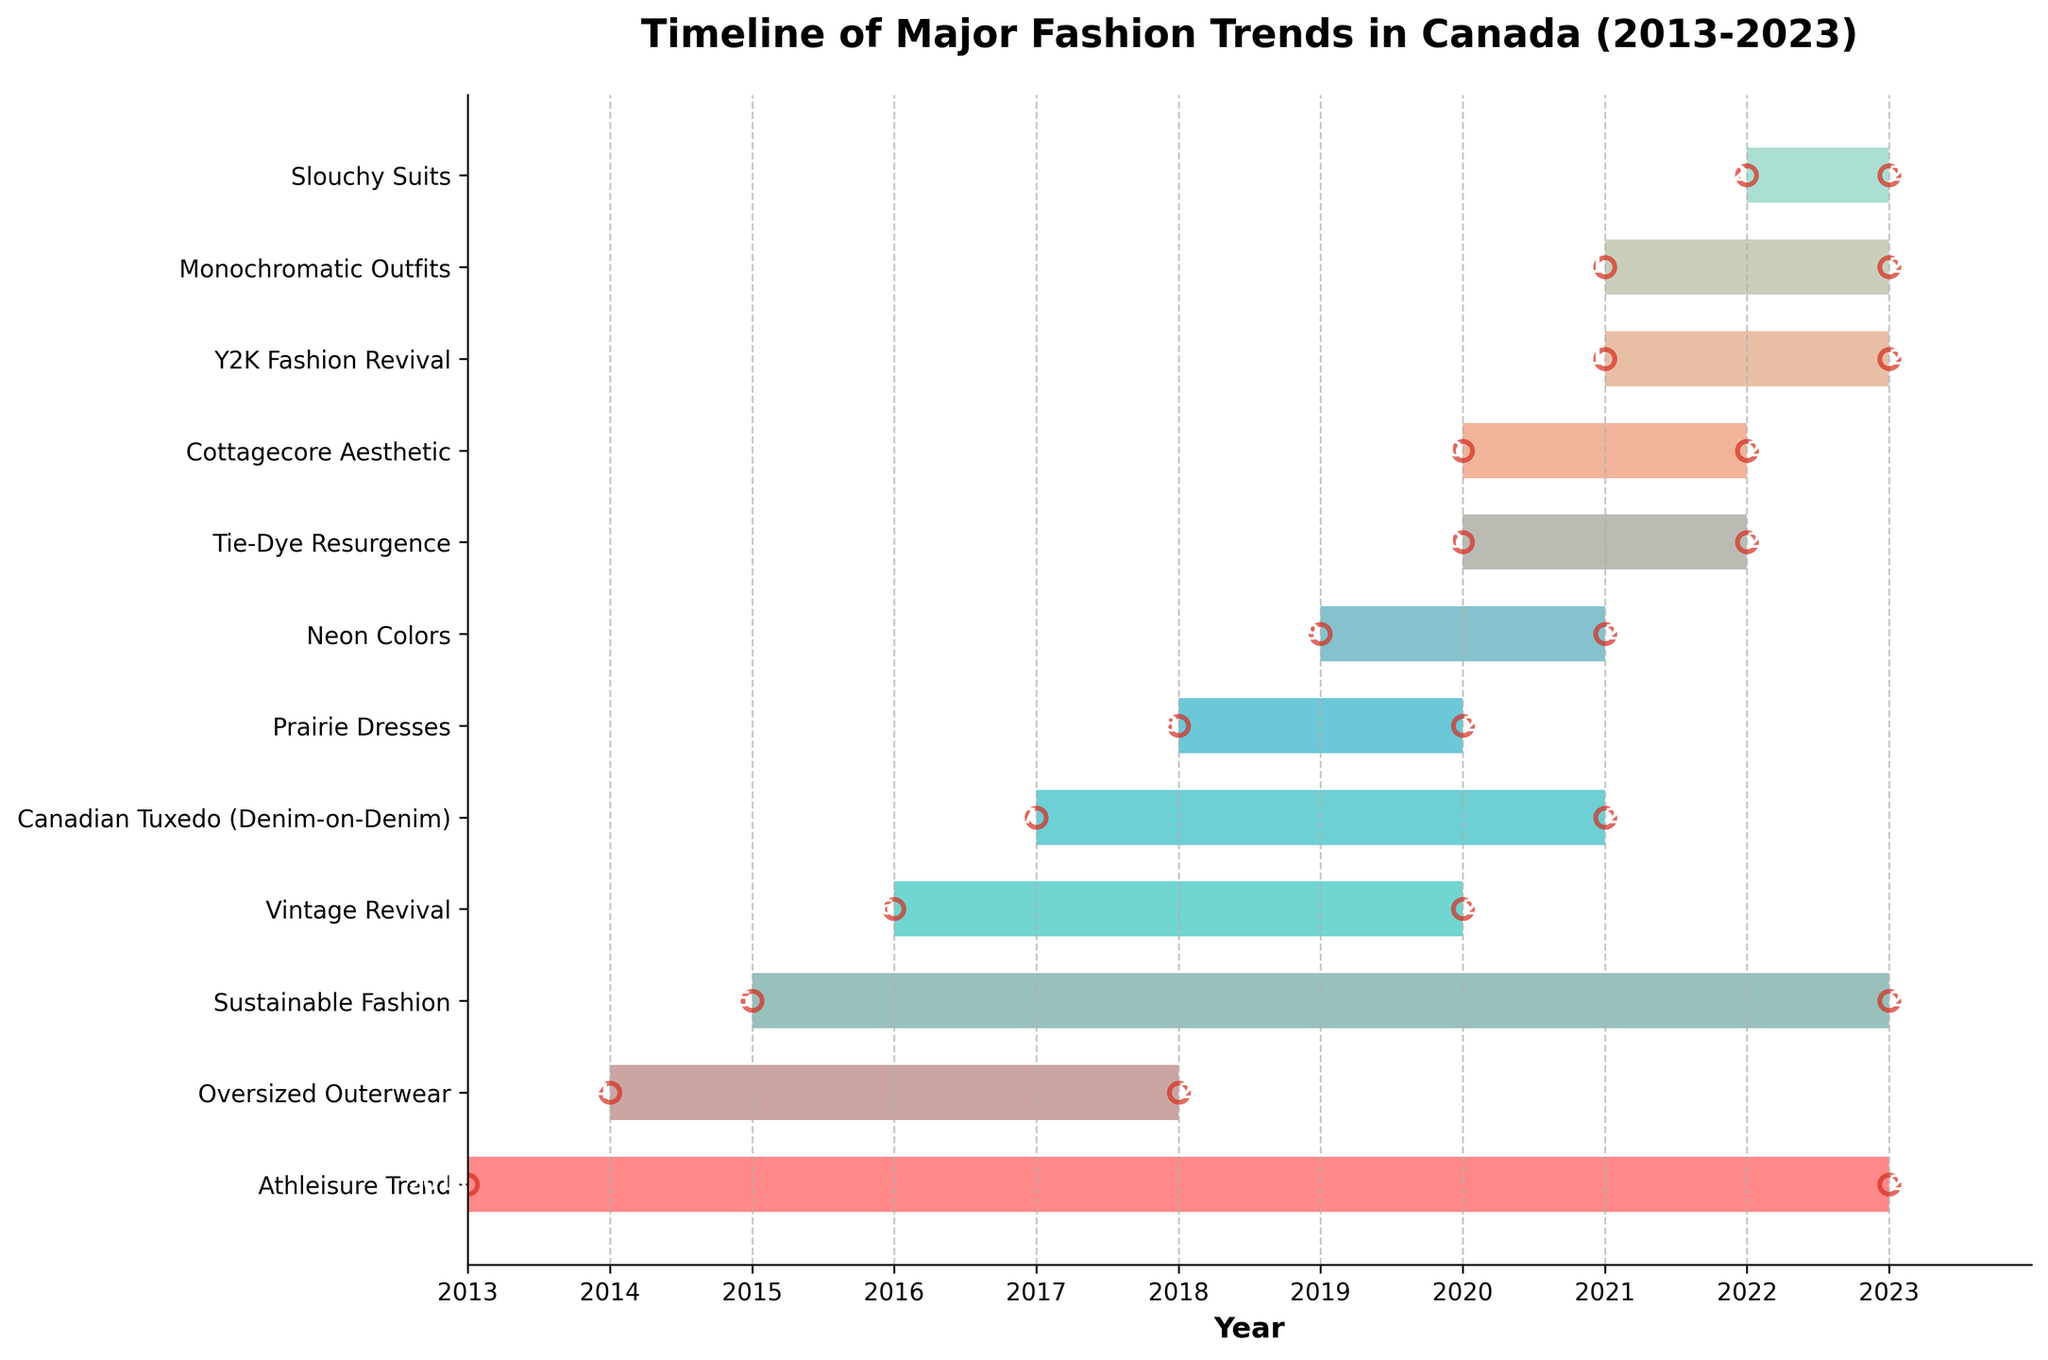Which trend lasted the longest? The trend that lasted the longest can be identified by comparing the start and end dates of all trends and finding the one with the maximum duration. Here, Athleisure Trend (2013-2023) and Sustainable Fashion (2015-2023) both lasted for 10 years.
Answer: Athleisure Trend and Sustainable Fashion How many trends started after 2018? To find the number of trends that started after 2018, count all trends with a start date of 2019 or later. These trends are Neon Colors (2019), Tie-Dye Resurgence (2020), Cottagecore Aesthetic (2020), Y2K Fashion Revival (2021), Monochromatic Outfits (2021), Slouchy Suits (2022).
Answer: 6 Which trend had the shortest duration? To determine the shortest trend duration, compare the duration of each trend. Prairie Dresses (2018-2020), which lasted 2 years, is the shortest.
Answer: Prairie Dresses Which trends were active in 2020? To find trends active in 2020, check which trends include 2020 in their duration. These are Sustainable Fashion, Vintage Revival, Canadian Tuxedo, Prairie Dresses, Neon Colors, Tie-Dye Resurgence, Cottagecore Aesthetic.
Answer: 7 trends Did any trend start and end within the same year? Check for trends where the start and end years are equal. As observed, no trend starts and ends within the same year.
Answer: No How many trends were active in both 2021 and 2022? Check the trends that overlap with both 2021 and 2022 years. These include: Sustainable Fashion, Neon Colors, Tie-Dye Resurgence, Cottagecore Aesthetic, Y2K Fashion Revival, Monochromatic Outfits.
Answer: 6 Which trends overlapped with the Canadian Tuxedo trend? To identify trends overlapping with Canadian Tuxedo (2017-2021), check other trends active during any part of this period. These include Sustainable Fashion, Vintage Revival, Prairie Dresses, Neon Colors.
Answer: 4 trends Which trends started in the same year? Identify trends by looking at the start years. Tie-Dye Resurgence and Cottagecore Aesthetic both started in 2020. Similarly, Y2K Fashion Revival and Monochromatic Outfits started in 2021.
Answer: Tie-Dye Resurgence & Cottagecore Aesthetic, Y2K Fashion Revival & Monochromatic Outfits 